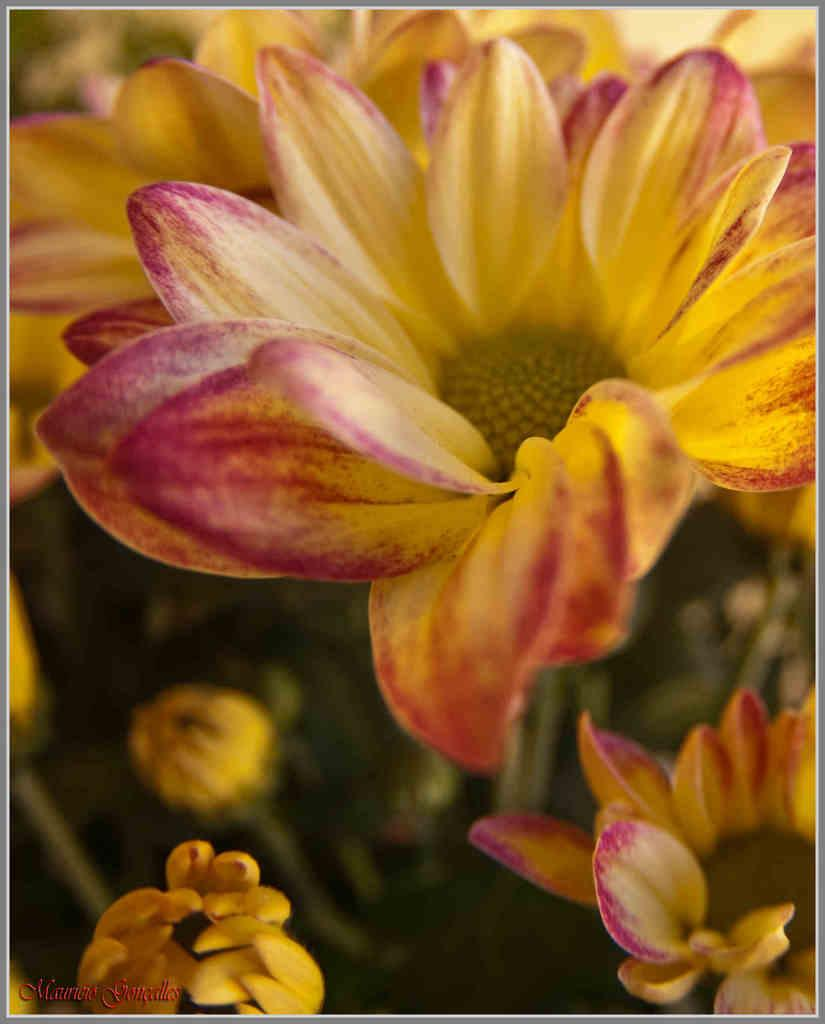What is located at the front of the image? There are flowers in the front of the image. How would you describe the background of the image? The background of the image is blurry. Where is the text located in the image? The text is at the left bottom of the image. What type of juice is being served at the school in the image? There is no mention of juice, school, or trains in the image, so it is not possible to answer that question. 